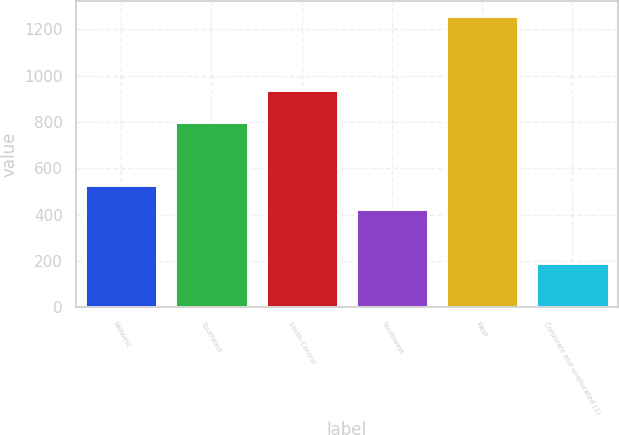Convert chart. <chart><loc_0><loc_0><loc_500><loc_500><bar_chart><fcel>Midwest<fcel>Southeast<fcel>South Central<fcel>Southwest<fcel>West<fcel>Corporate and unallocated (3)<nl><fcel>530.08<fcel>799.6<fcel>939.7<fcel>423.6<fcel>1258.4<fcel>193.6<nl></chart> 